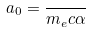<formula> <loc_0><loc_0><loc_500><loc_500>a _ { 0 } = \frac { } { m _ { e } c \alpha }</formula> 